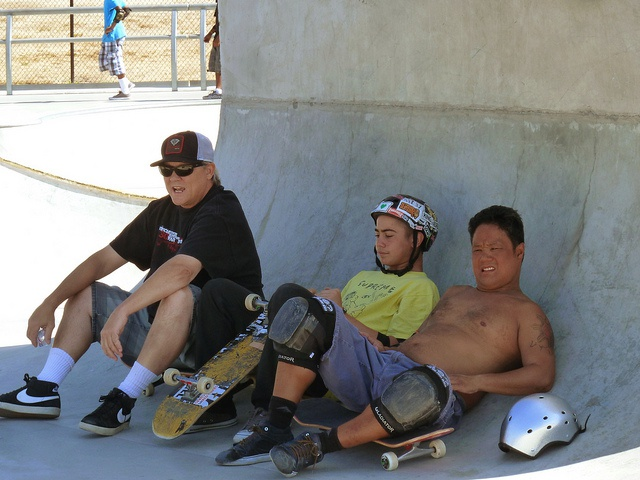Describe the objects in this image and their specific colors. I can see people in beige, black, gray, brown, and maroon tones, people in beige, black, and gray tones, people in beige, black, olive, gray, and brown tones, skateboard in beige, gray, olive, black, and darkgray tones, and skateboard in beige, black, gray, and darkgray tones in this image. 